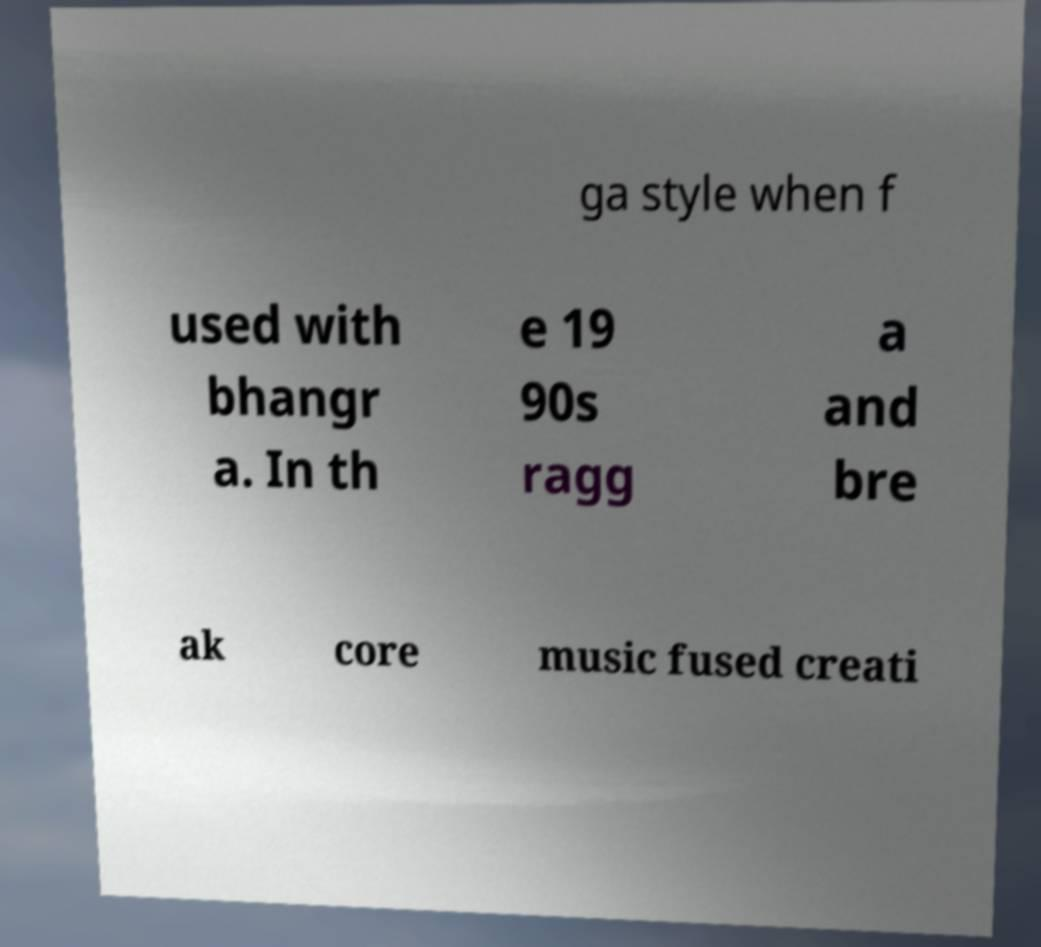Can you read and provide the text displayed in the image?This photo seems to have some interesting text. Can you extract and type it out for me? ga style when f used with bhangr a. In th e 19 90s ragg a and bre ak core music fused creati 